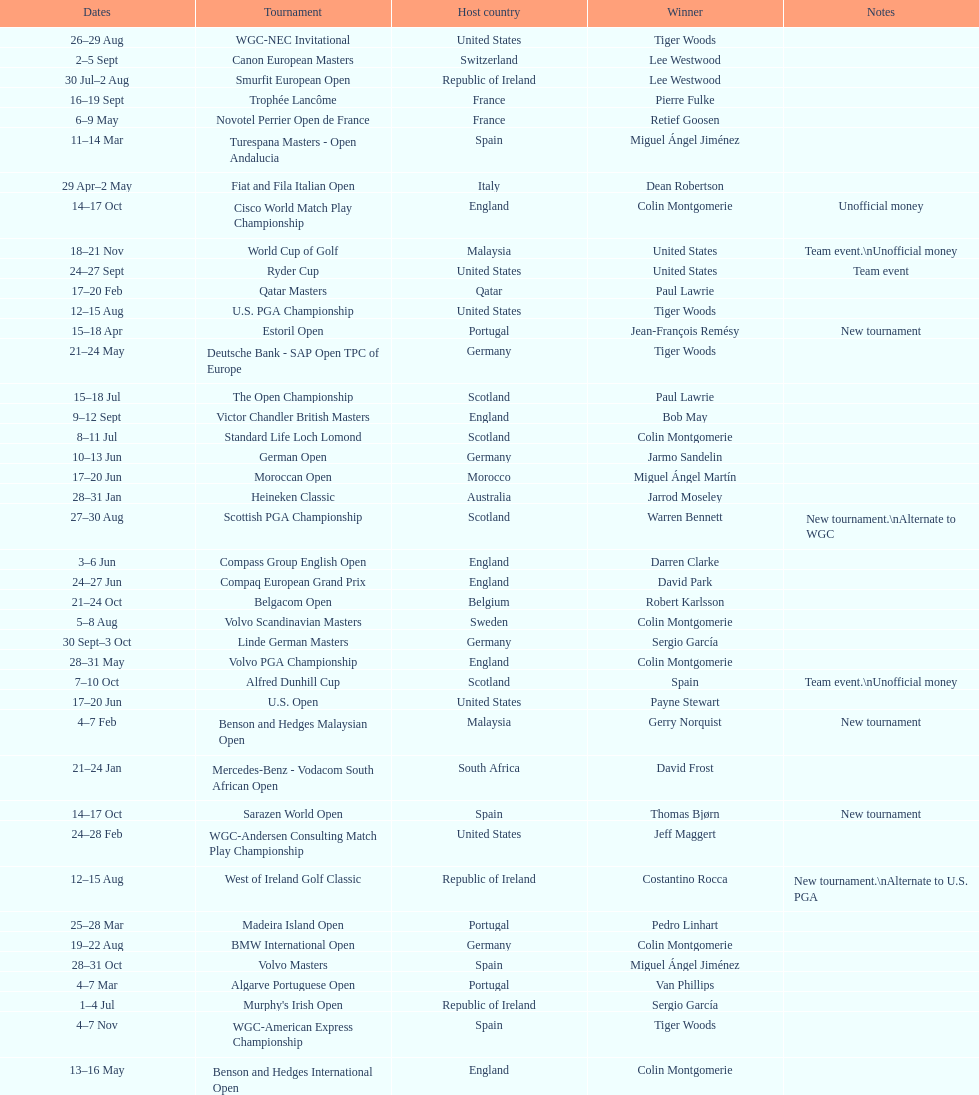How many tournaments began before aug 15th 31. 